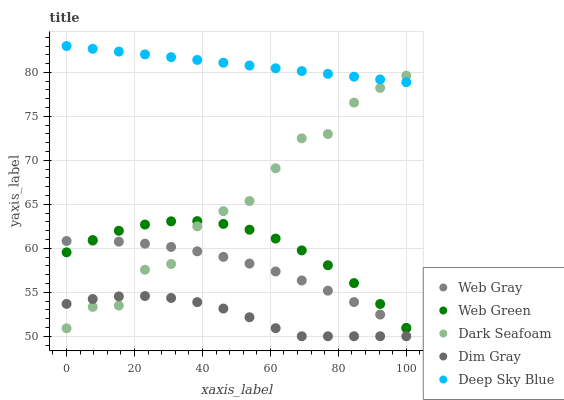Does Dim Gray have the minimum area under the curve?
Answer yes or no. Yes. Does Deep Sky Blue have the maximum area under the curve?
Answer yes or no. Yes. Does Dark Seafoam have the minimum area under the curve?
Answer yes or no. No. Does Dark Seafoam have the maximum area under the curve?
Answer yes or no. No. Is Deep Sky Blue the smoothest?
Answer yes or no. Yes. Is Dark Seafoam the roughest?
Answer yes or no. Yes. Is Web Gray the smoothest?
Answer yes or no. No. Is Web Gray the roughest?
Answer yes or no. No. Does Dim Gray have the lowest value?
Answer yes or no. Yes. Does Dark Seafoam have the lowest value?
Answer yes or no. No. Does Deep Sky Blue have the highest value?
Answer yes or no. Yes. Does Dark Seafoam have the highest value?
Answer yes or no. No. Is Dim Gray less than Web Green?
Answer yes or no. Yes. Is Web Green greater than Dim Gray?
Answer yes or no. Yes. Does Dim Gray intersect Dark Seafoam?
Answer yes or no. Yes. Is Dim Gray less than Dark Seafoam?
Answer yes or no. No. Is Dim Gray greater than Dark Seafoam?
Answer yes or no. No. Does Dim Gray intersect Web Green?
Answer yes or no. No. 